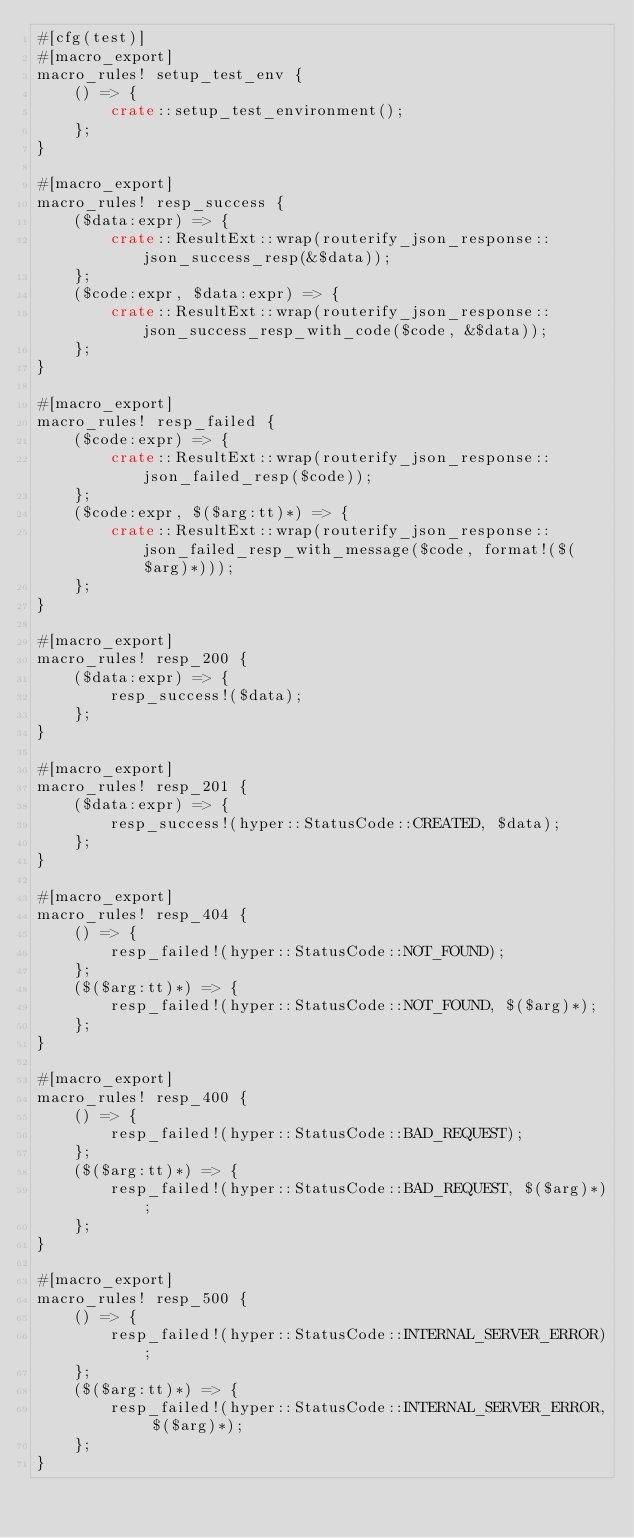Convert code to text. <code><loc_0><loc_0><loc_500><loc_500><_Rust_>#[cfg(test)]
#[macro_export]
macro_rules! setup_test_env {
    () => {
        crate::setup_test_environment();
    };
}

#[macro_export]
macro_rules! resp_success {
    ($data:expr) => {
        crate::ResultExt::wrap(routerify_json_response::json_success_resp(&$data));
    };
    ($code:expr, $data:expr) => {
        crate::ResultExt::wrap(routerify_json_response::json_success_resp_with_code($code, &$data));
    };
}

#[macro_export]
macro_rules! resp_failed {
    ($code:expr) => {
        crate::ResultExt::wrap(routerify_json_response::json_failed_resp($code));
    };
    ($code:expr, $($arg:tt)*) => {
        crate::ResultExt::wrap(routerify_json_response::json_failed_resp_with_message($code, format!($($arg)*)));
    };
}

#[macro_export]
macro_rules! resp_200 {
    ($data:expr) => {
        resp_success!($data);
    };
}

#[macro_export]
macro_rules! resp_201 {
    ($data:expr) => {
        resp_success!(hyper::StatusCode::CREATED, $data);
    };
}

#[macro_export]
macro_rules! resp_404 {
    () => {
        resp_failed!(hyper::StatusCode::NOT_FOUND);
    };
    ($($arg:tt)*) => {
        resp_failed!(hyper::StatusCode::NOT_FOUND, $($arg)*);
    };
}

#[macro_export]
macro_rules! resp_400 {
    () => {
        resp_failed!(hyper::StatusCode::BAD_REQUEST);
    };
    ($($arg:tt)*) => {
        resp_failed!(hyper::StatusCode::BAD_REQUEST, $($arg)*);
    };
}

#[macro_export]
macro_rules! resp_500 {
    () => {
        resp_failed!(hyper::StatusCode::INTERNAL_SERVER_ERROR);
    };
    ($($arg:tt)*) => {
        resp_failed!(hyper::StatusCode::INTERNAL_SERVER_ERROR, $($arg)*);
    };
}
</code> 